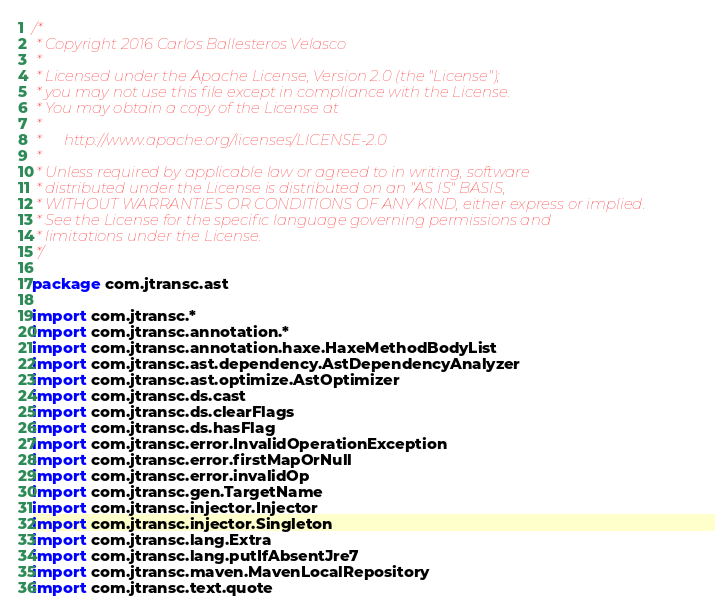<code> <loc_0><loc_0><loc_500><loc_500><_Kotlin_>/*
 * Copyright 2016 Carlos Ballesteros Velasco
 *
 * Licensed under the Apache License, Version 2.0 (the "License");
 * you may not use this file except in compliance with the License.
 * You may obtain a copy of the License at
 *
 *      http://www.apache.org/licenses/LICENSE-2.0
 *
 * Unless required by applicable law or agreed to in writing, software
 * distributed under the License is distributed on an "AS IS" BASIS,
 * WITHOUT WARRANTIES OR CONDITIONS OF ANY KIND, either express or implied.
 * See the License for the specific language governing permissions and
 * limitations under the License.
 */

package com.jtransc.ast

import com.jtransc.*
import com.jtransc.annotation.*
import com.jtransc.annotation.haxe.HaxeMethodBodyList
import com.jtransc.ast.dependency.AstDependencyAnalyzer
import com.jtransc.ast.optimize.AstOptimizer
import com.jtransc.ds.cast
import com.jtransc.ds.clearFlags
import com.jtransc.ds.hasFlag
import com.jtransc.error.InvalidOperationException
import com.jtransc.error.firstMapOrNull
import com.jtransc.error.invalidOp
import com.jtransc.gen.TargetName
import com.jtransc.injector.Injector
import com.jtransc.injector.Singleton
import com.jtransc.lang.Extra
import com.jtransc.lang.putIfAbsentJre7
import com.jtransc.maven.MavenLocalRepository
import com.jtransc.text.quote</code> 